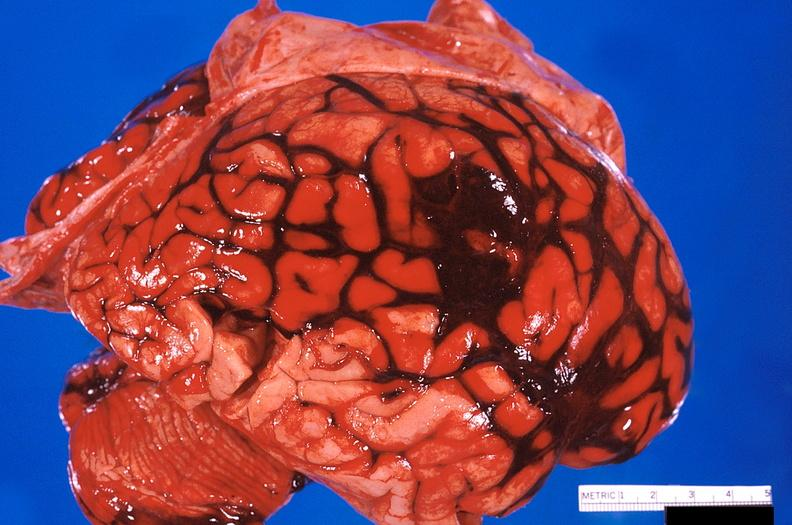s cardiovascular present?
Answer the question using a single word or phrase. No 